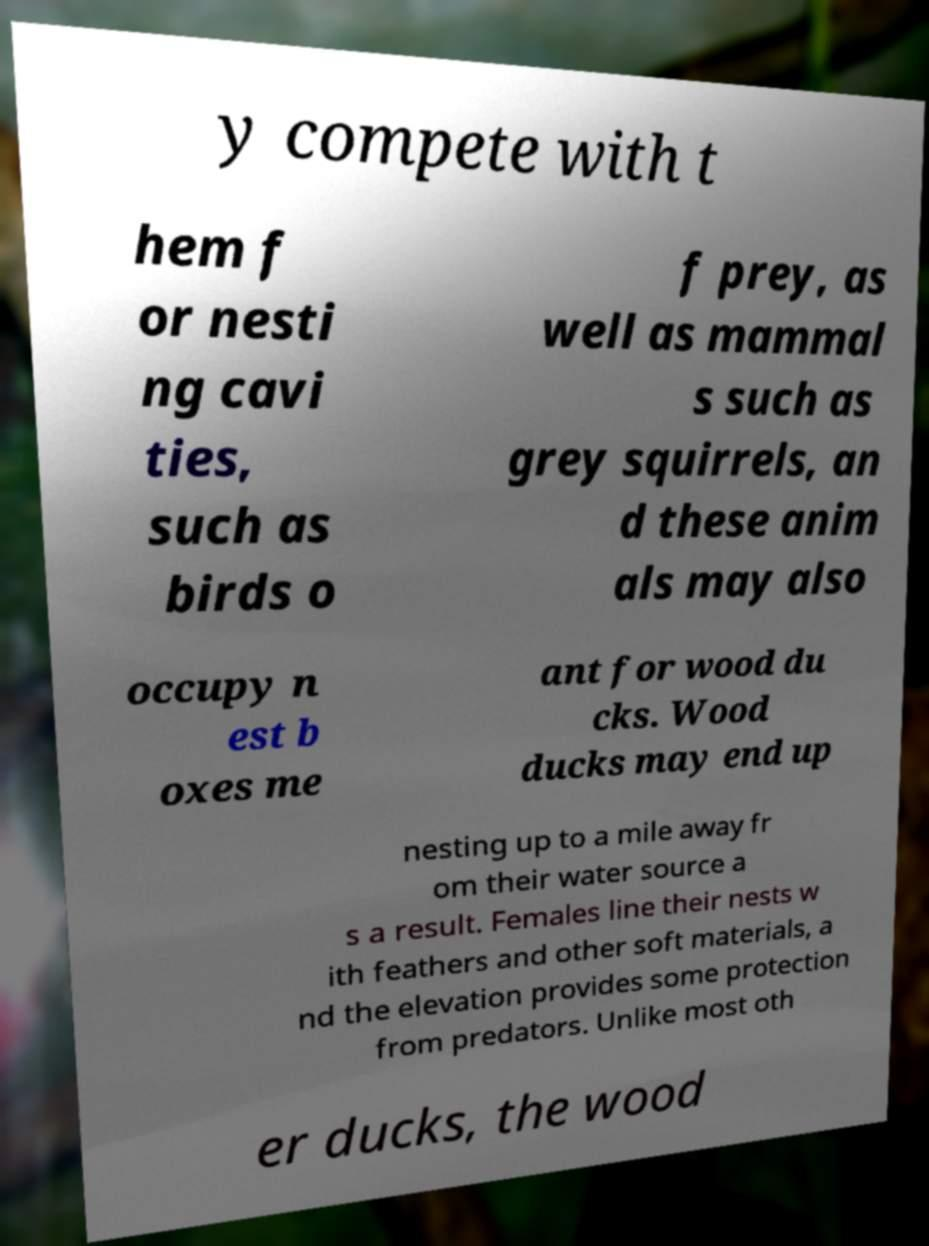Can you accurately transcribe the text from the provided image for me? y compete with t hem f or nesti ng cavi ties, such as birds o f prey, as well as mammal s such as grey squirrels, an d these anim als may also occupy n est b oxes me ant for wood du cks. Wood ducks may end up nesting up to a mile away fr om their water source a s a result. Females line their nests w ith feathers and other soft materials, a nd the elevation provides some protection from predators. Unlike most oth er ducks, the wood 